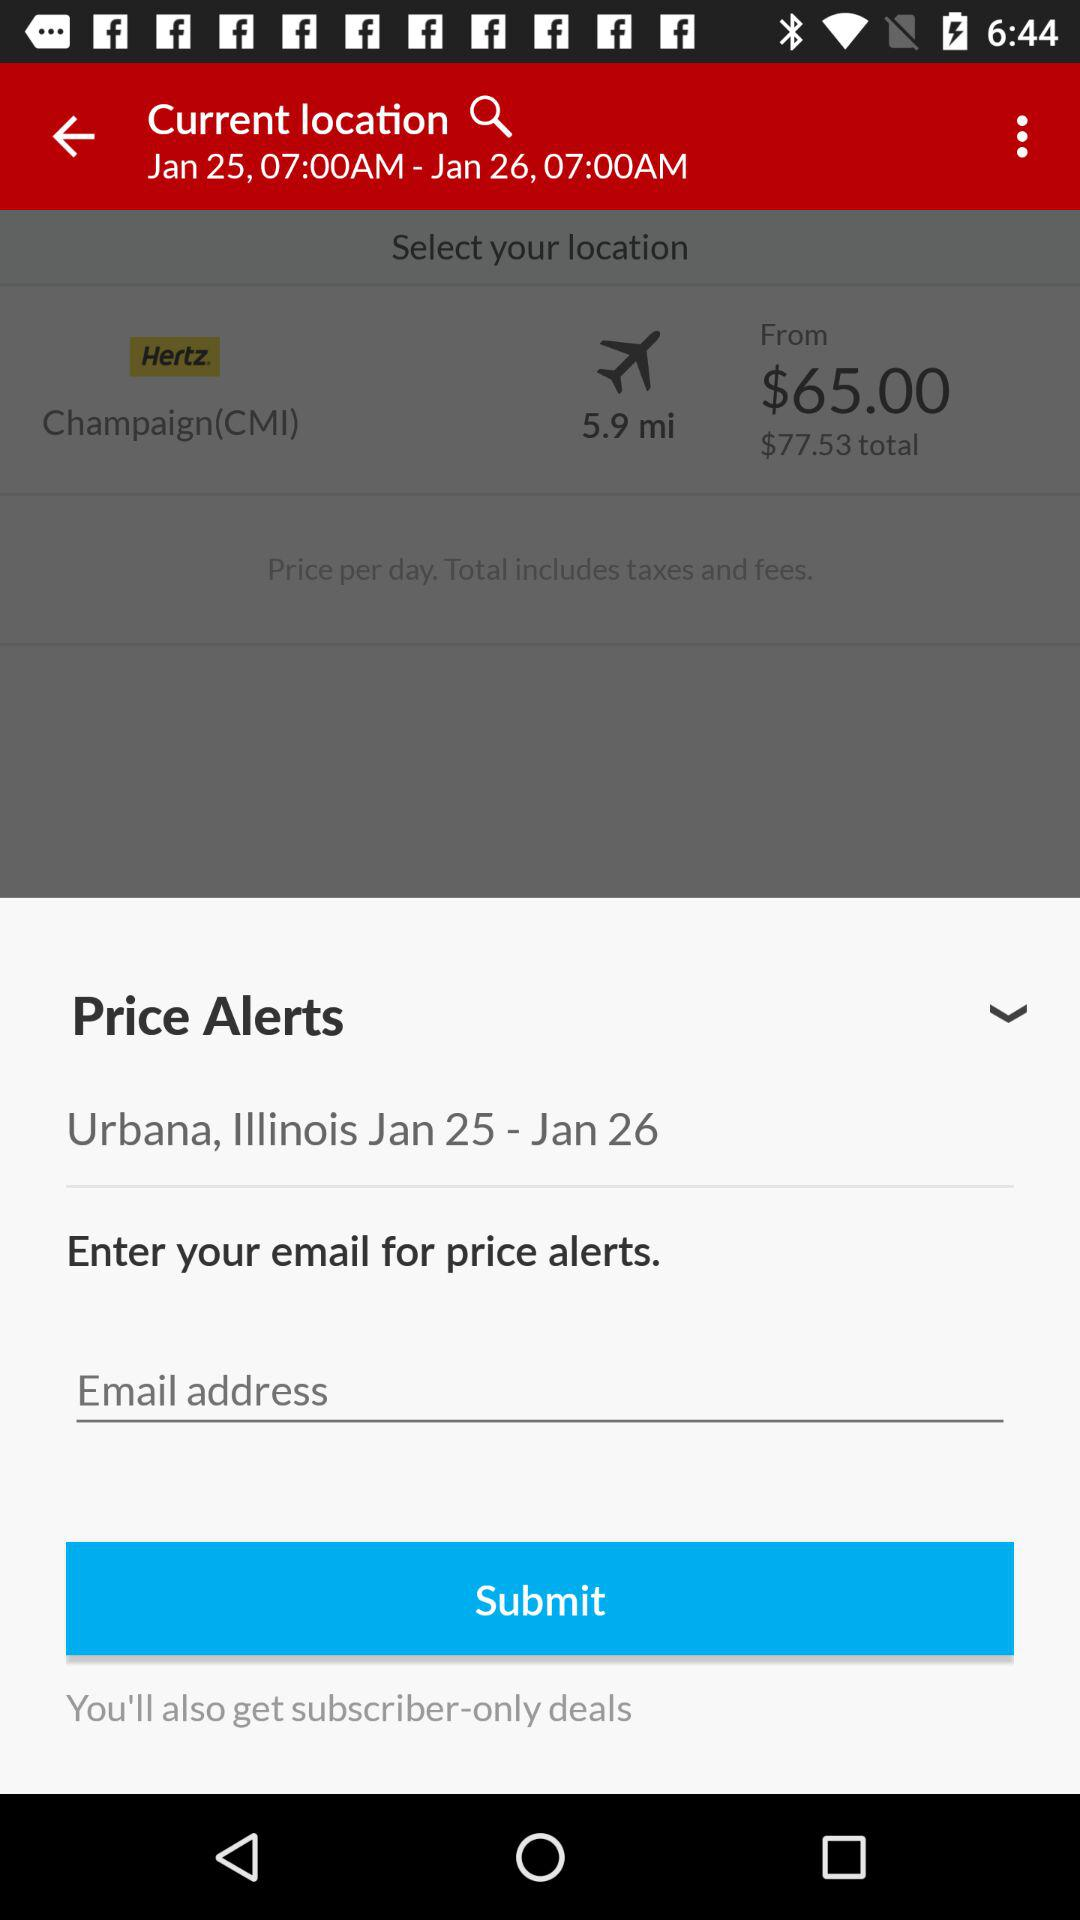What is the mentioned location? The mentioned locations are Champaign (CMI) and Urbana, Illinois. 